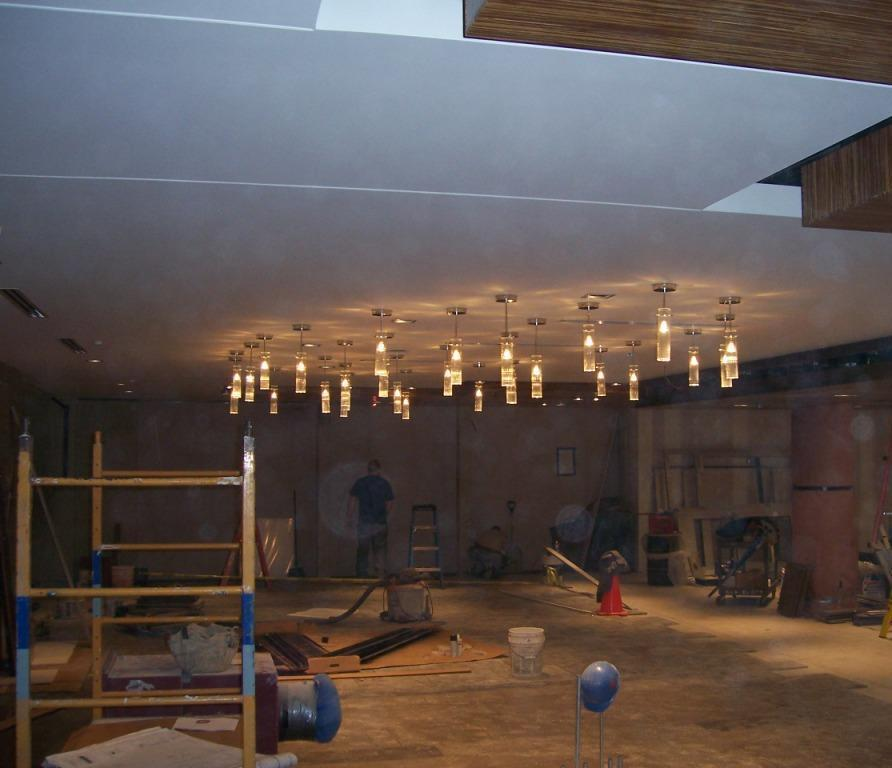Where was the image taken? The image was taken inside a room. What can be found in the room? There are tools, furniture, and other unspecified items in the room. Can you describe the person in the background of the room? A person is standing in the background of the room. What type of lighting is present in the room? There are lights on the ceiling of the room. Can you see a goat on the dock in the image? There is no goat or dock present in the image; it was taken inside a room. What part of the brain is visible in the image? There is no brain visible in the image; it features a room with tools, furniture, and other items. 